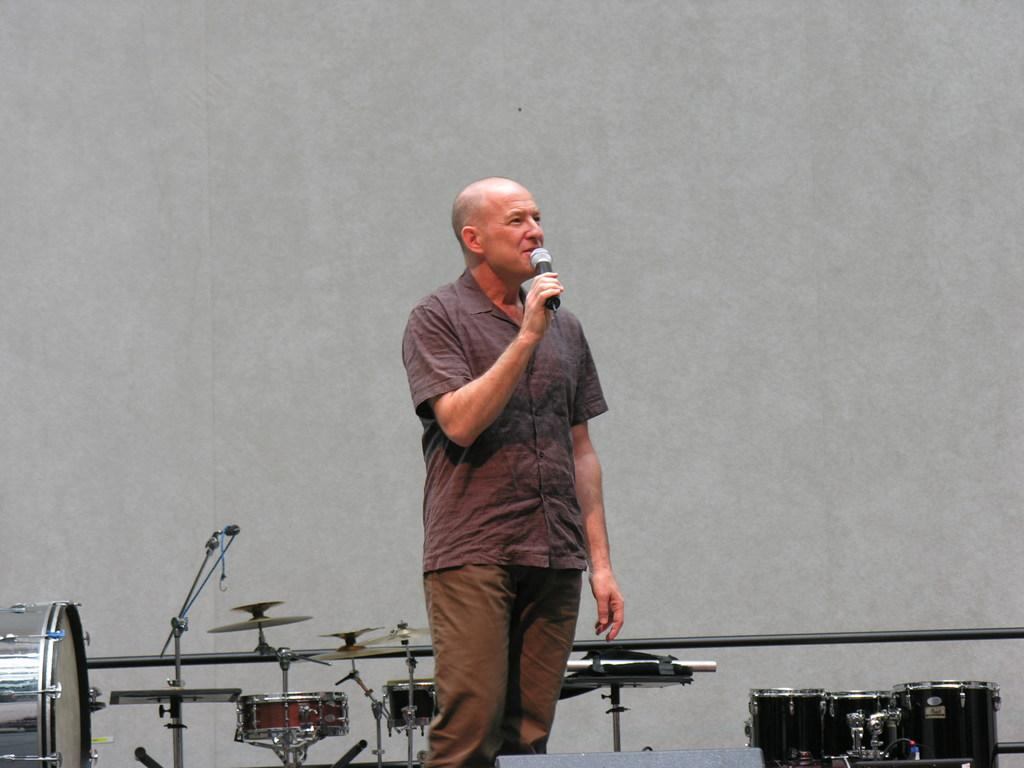What is the main subject of the image? The main subject of the image is a man. What is the man doing in the image? The man is standing and talking in the image. What object is the man holding in his hand? The man is holding a microphone in his hand. What can be seen in the background of the image? There are musical instruments and a wall in the background of the image. Can you tell me the total cost of the items listed on the receipt in the image? There is no receipt present in the image; it features a man standing and talking while holding a microphone, with musical instruments and a wall in the background. 